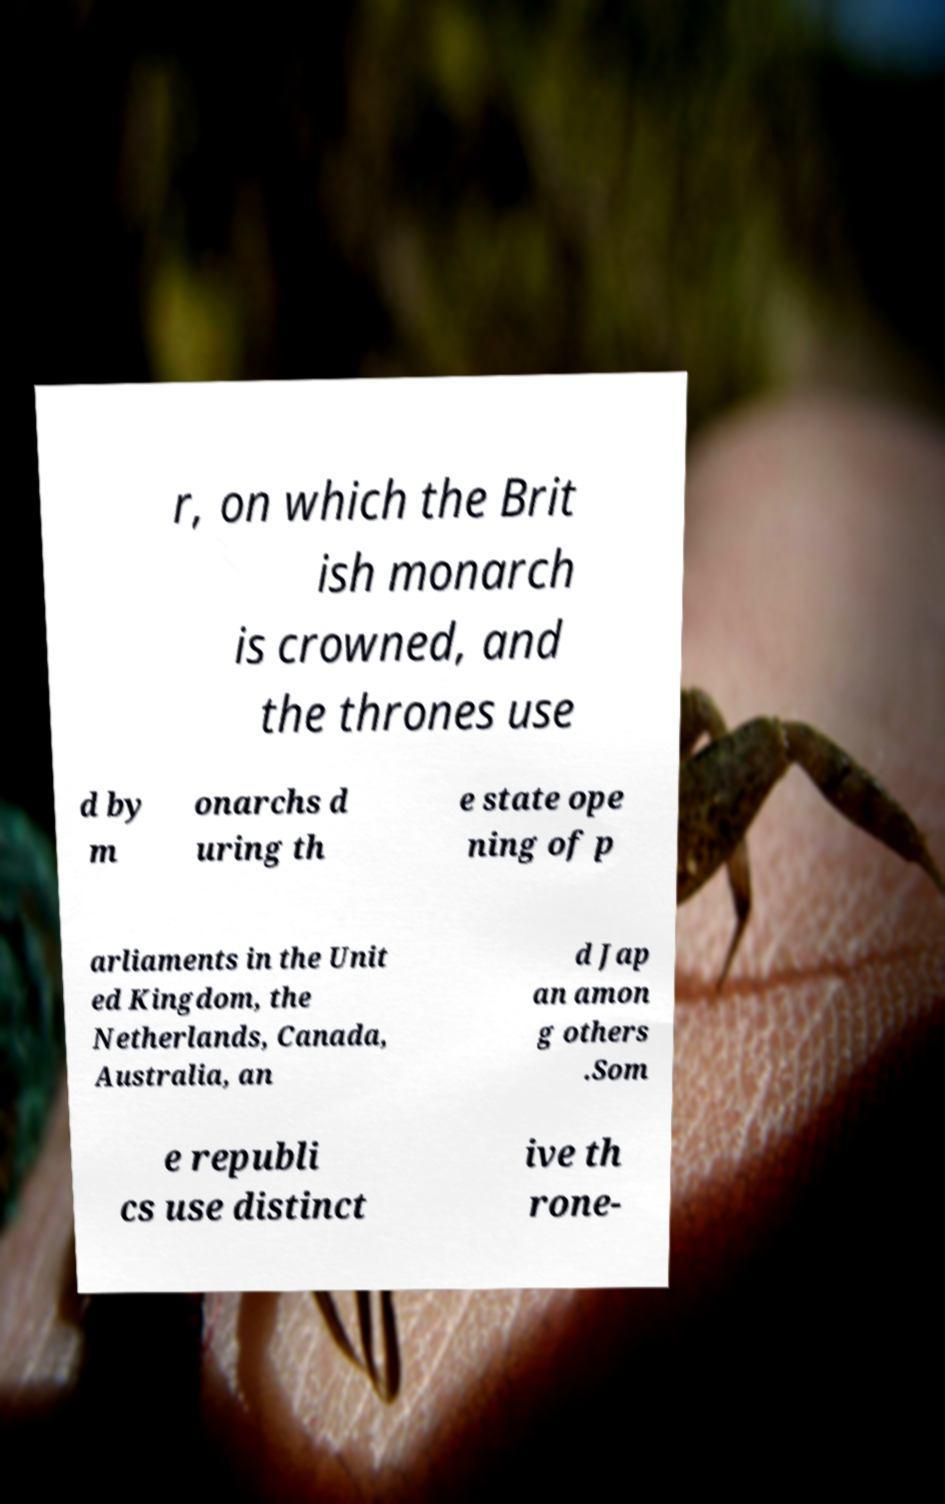Can you read and provide the text displayed in the image?This photo seems to have some interesting text. Can you extract and type it out for me? r, on which the Brit ish monarch is crowned, and the thrones use d by m onarchs d uring th e state ope ning of p arliaments in the Unit ed Kingdom, the Netherlands, Canada, Australia, an d Jap an amon g others .Som e republi cs use distinct ive th rone- 